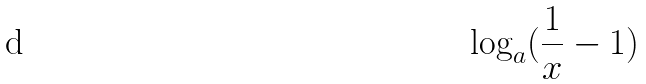<formula> <loc_0><loc_0><loc_500><loc_500>\log _ { a } ( \frac { 1 } { x } - 1 )</formula> 